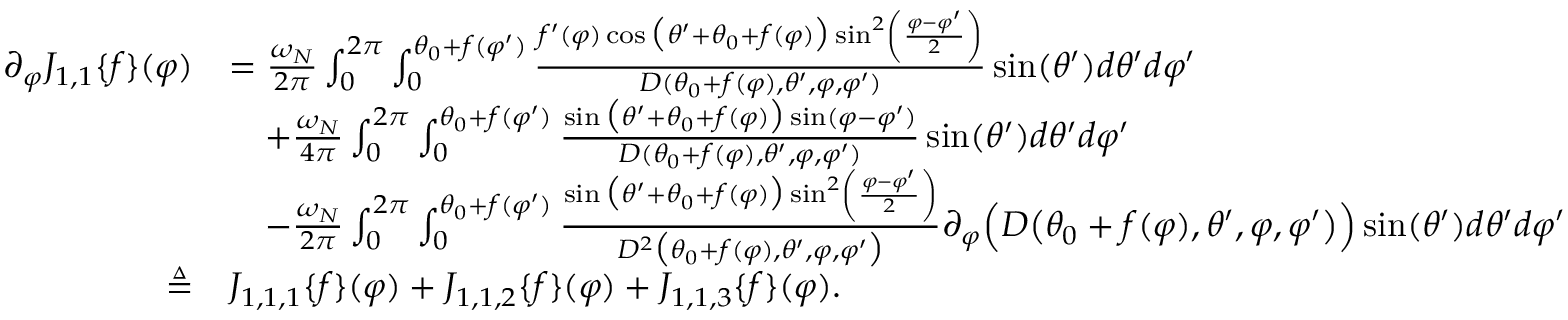Convert formula to latex. <formula><loc_0><loc_0><loc_500><loc_500>\begin{array} { r l } { \partial _ { \varphi } J _ { 1 , 1 } \{ f \} ( \varphi ) } & { = \frac { \omega _ { N } } { 2 \pi } \int _ { 0 } ^ { 2 \pi } \int _ { 0 } ^ { \theta _ { 0 } + f ( \varphi ^ { \prime } ) } \frac { f ^ { \prime } ( \varphi ) \cos \left ( \theta ^ { \prime } + \theta _ { 0 } + f ( \varphi ) \right ) \sin ^ { 2 } \left ( \frac { \varphi - \varphi ^ { \prime } } { 2 } \right ) } { D ( \theta _ { 0 } + f ( \varphi ) , \theta ^ { \prime } , \varphi , \varphi ^ { \prime } ) } \sin ( \theta ^ { \prime } ) d \theta ^ { \prime } d \varphi ^ { \prime } } \\ & { \quad + \frac { \omega _ { N } } { 4 \pi } \int _ { 0 } ^ { 2 \pi } \int _ { 0 } ^ { \theta _ { 0 } + f ( \varphi ^ { \prime } ) } \frac { \sin \left ( \theta ^ { \prime } + \theta _ { 0 } + f ( \varphi ) \right ) \sin ( \varphi - \varphi ^ { \prime } ) } { D ( \theta _ { 0 } + f ( \varphi ) , \theta ^ { \prime } , \varphi , \varphi ^ { \prime } ) } \sin ( \theta ^ { \prime } ) d \theta ^ { \prime } d \varphi ^ { \prime } } \\ & { \quad - \frac { \omega _ { N } } { 2 \pi } \int _ { 0 } ^ { 2 \pi } \int _ { 0 } ^ { \theta _ { 0 } + f ( \varphi ^ { \prime } ) } \frac { \sin \left ( \theta ^ { \prime } + \theta _ { 0 } + f ( \varphi ) \right ) \sin ^ { 2 } \left ( \frac { \varphi - \varphi ^ { \prime } } { 2 } \right ) } { D ^ { 2 } \left ( \theta _ { 0 } + f ( \varphi ) , \theta ^ { \prime } , \varphi , \varphi ^ { \prime } \right ) } \partial _ { \varphi } \left ( D \left ( \theta _ { 0 } + f ( \varphi ) , \theta ^ { \prime } , \varphi , \varphi ^ { \prime } \right ) \right ) \sin ( \theta ^ { \prime } ) d \theta ^ { \prime } d \varphi ^ { \prime } } \\ { \triangle q } & { J _ { 1 , 1 , 1 } \{ f \} ( \varphi ) + J _ { 1 , 1 , 2 } \{ f \} ( \varphi ) + J _ { 1 , 1 , 3 } \{ f \} ( \varphi ) . } \end{array}</formula> 